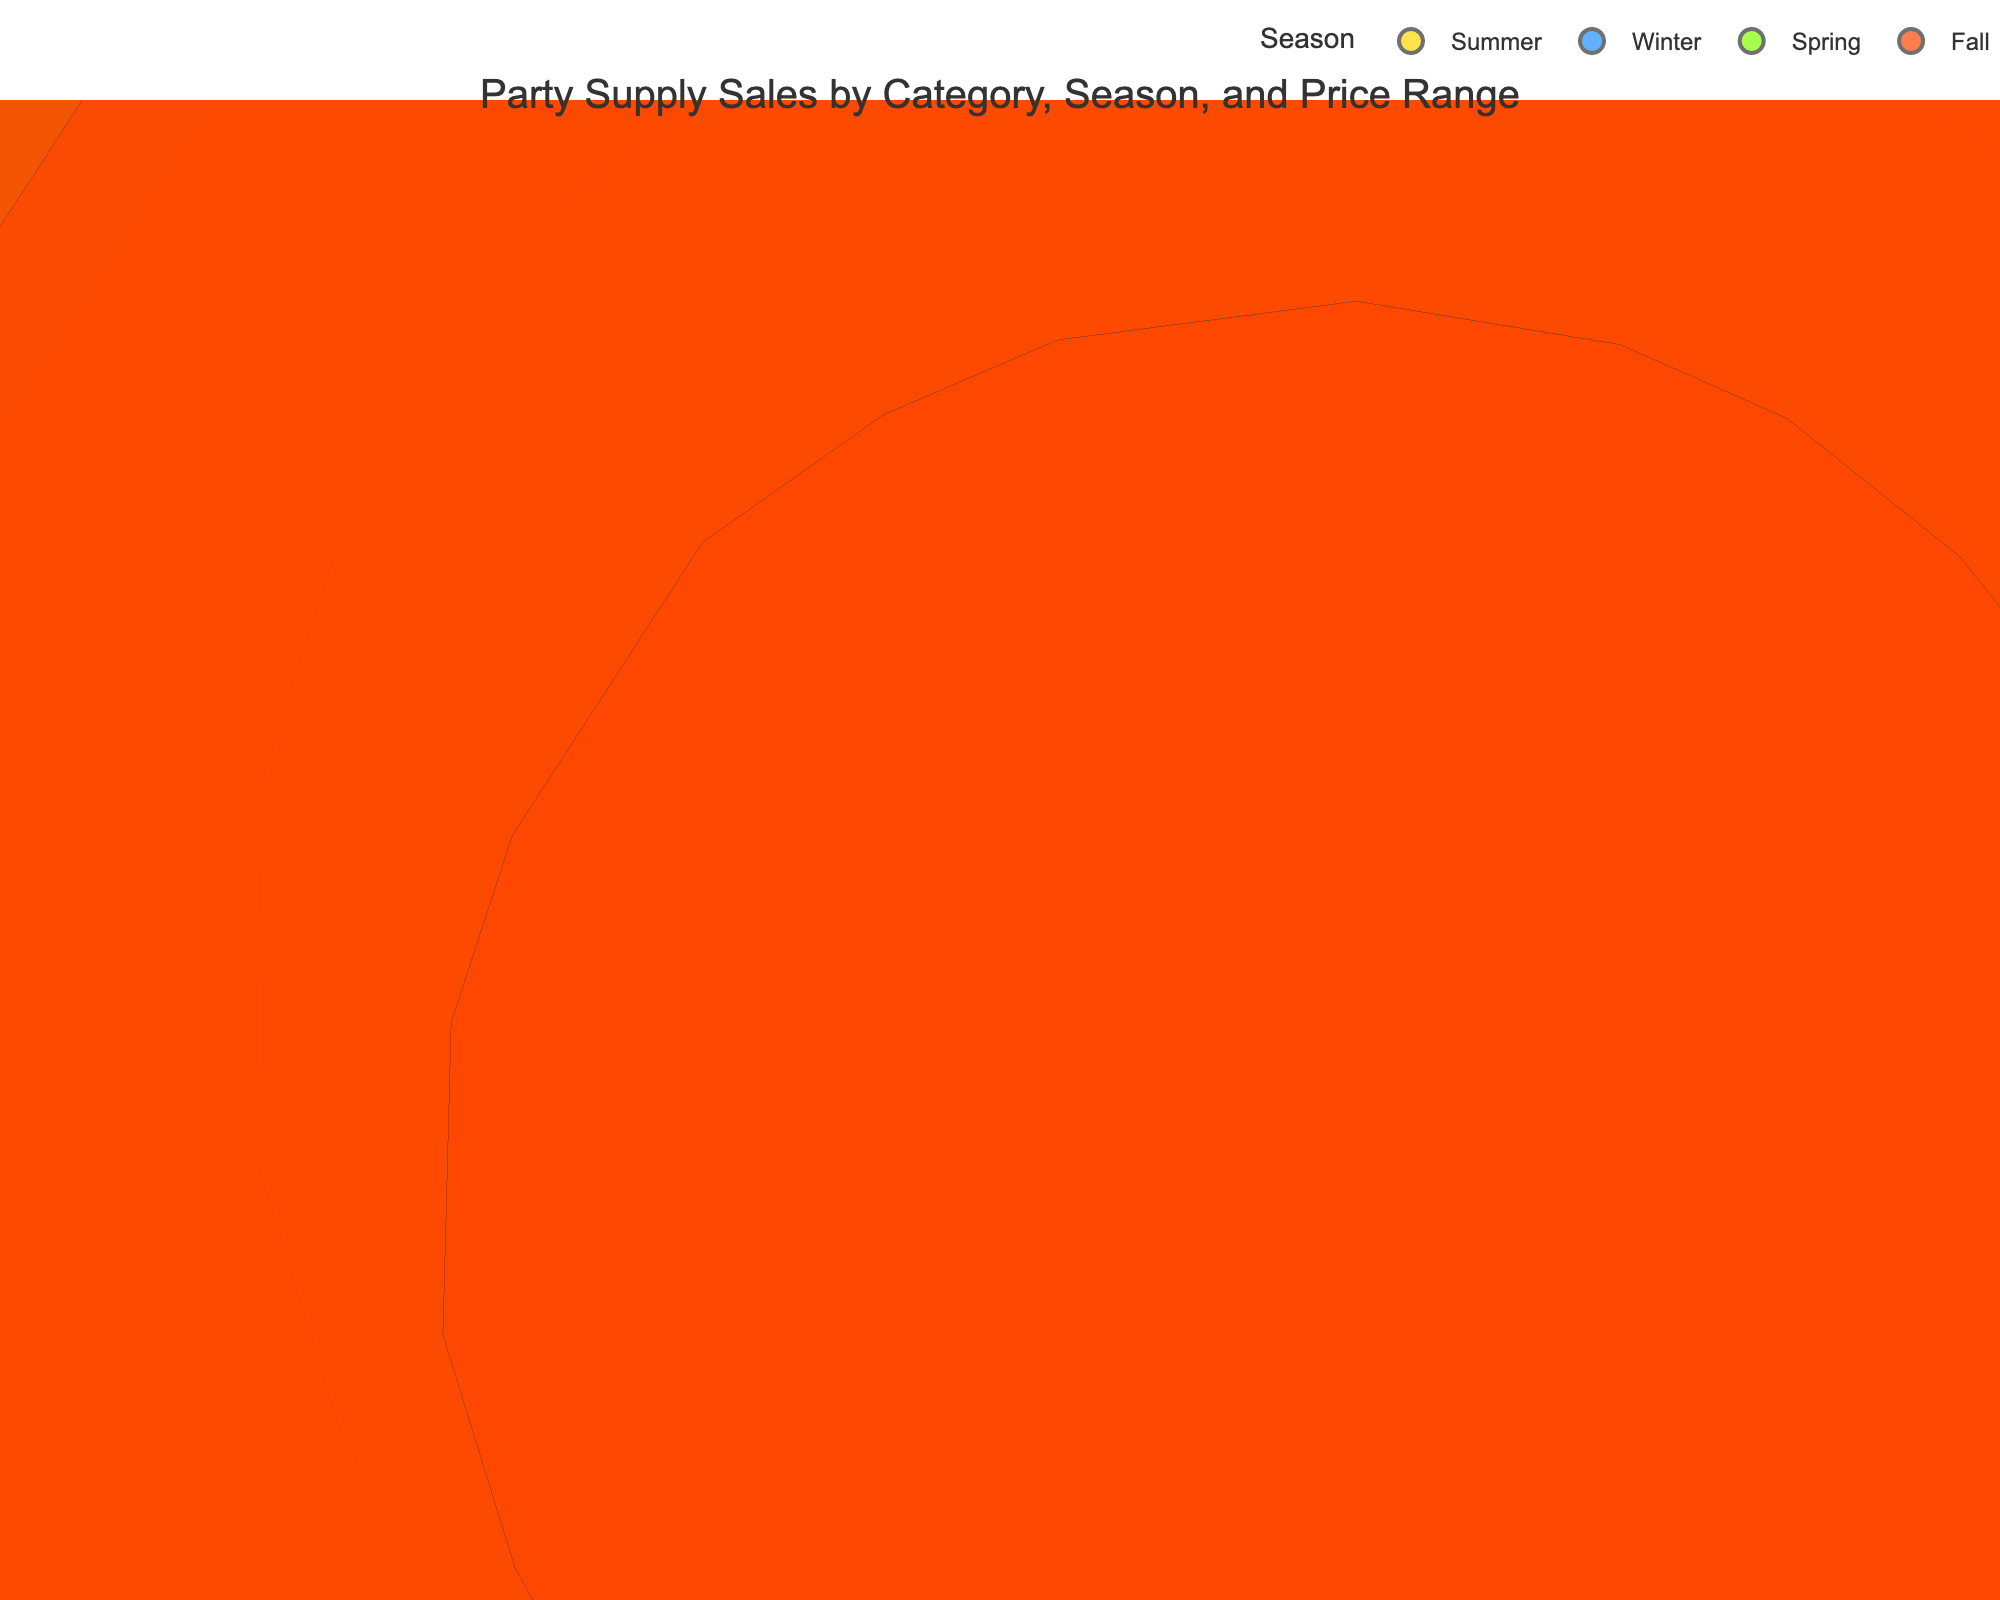What is the title of the figure? The title is usually displayed at the top of the chart. It provides an overview of what the chart represents. In this case, the title reads "Party Supply Sales by Category, Season, and Price Range."
Answer: Party Supply Sales by Category, Season, and Price Range Which season has the highest sales volume for balloons? To determine the highest sales volume for balloons, we look for "Balloons" along the category axis and compare the sales volume of different seasons. The largest bubble for balloons appears in the summer.
Answer: Summer What is the price range for the category with the highest sales volume overall? To find the category with the highest sales volume, we look for the largest bubble in the chart. The largest bubble belongs to "Goodie Bags" in the summer. For this bubble, the price range can be found by examining the additional information provided in the hover tooltip or nearby legends.
Answer: Low What are the sales volumes for Pinatas in each season? To find the sales volumes for Pinatas, we identify the bubbles labeled "Pinatas" and then check the corresponding positions along the sales volume axis for each season. The sales volumes for Pinatas across seasons are: Spring (750), Summer (1300), and Fall (500).
Answer: Spring: 750, Summer: 1300, Fall: 500 Which category has the lowest sales volume in winter? To determine the lowest sales volume in winter, we focus on the "Winter" season bubbles and look for the smallest bubble. Upon inspection, the smallest winter bubble belongs to "Goodie Bags."
Answer: Goodie Bags Compare the sales volume of Tableware in different price ranges. To compare Tableware sales volume, we locate the bubbles for Tableware and compare their sizes across different price ranges by checking the hover tooltips. The sales volumes are: Low (1500), Medium (1800), and High (900).
Answer: Low: 1500, Medium: 1800, High: 900 What is the range of sales volumes for Decorations category? To find this, we locate all the bubbles for Decorations. The minimum and maximum sales volumes can be derived from the hover tooltips. Sales volumes range from 1100 (High, Spring) to 2000 (Low, Fall).
Answer: 1100 to 2000 Which category and season combination have a sales volume of 1200? To discover the combination with a sales volume of 1200, we check the hover tooltips for each bubble until we find the one that matches the value of 1200. The bubble that matches this is Balloons in the summer.
Answer: Balloons, Summer How does the sales volume of Party Hats in Summer compare to Winter? We identify the bubbles for Party Hats in both summer and winter and then compare their sales volumes. In Summer, the sales volume is 1100, and in Winter, it is 400. Therefore, Summer sales are higher.
Answer: Summer is higher Which season has consistently high sales volumes across all categories? To find out which season has consistently high sales volumes, we observe the size of bubbles across all categories for each season. Summer has relatively large bubbles across many categories, indicating consistently high sales volumes.
Answer: Summer 